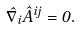Convert formula to latex. <formula><loc_0><loc_0><loc_500><loc_500>\hat { \nabla } _ { i } \hat { A } ^ { i j } = 0 .</formula> 